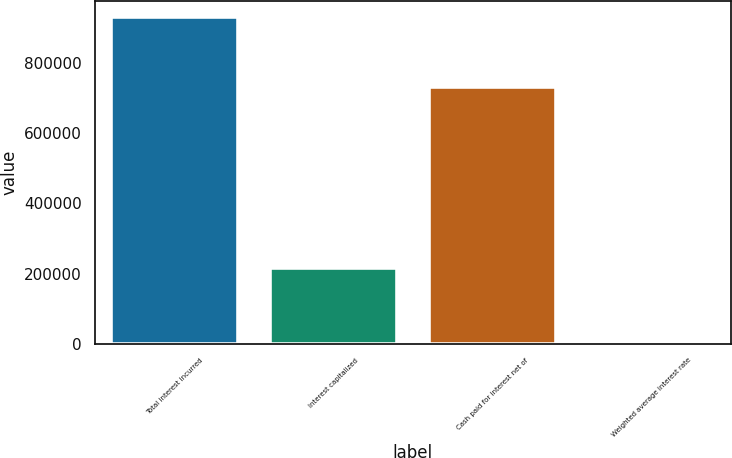Convert chart to OTSL. <chart><loc_0><loc_0><loc_500><loc_500><bar_chart><fcel>Total interest incurred<fcel>Interest capitalized<fcel>Cash paid for interest net of<fcel>Weighted average interest rate<nl><fcel>930138<fcel>215951<fcel>731618<fcel>7.1<nl></chart> 